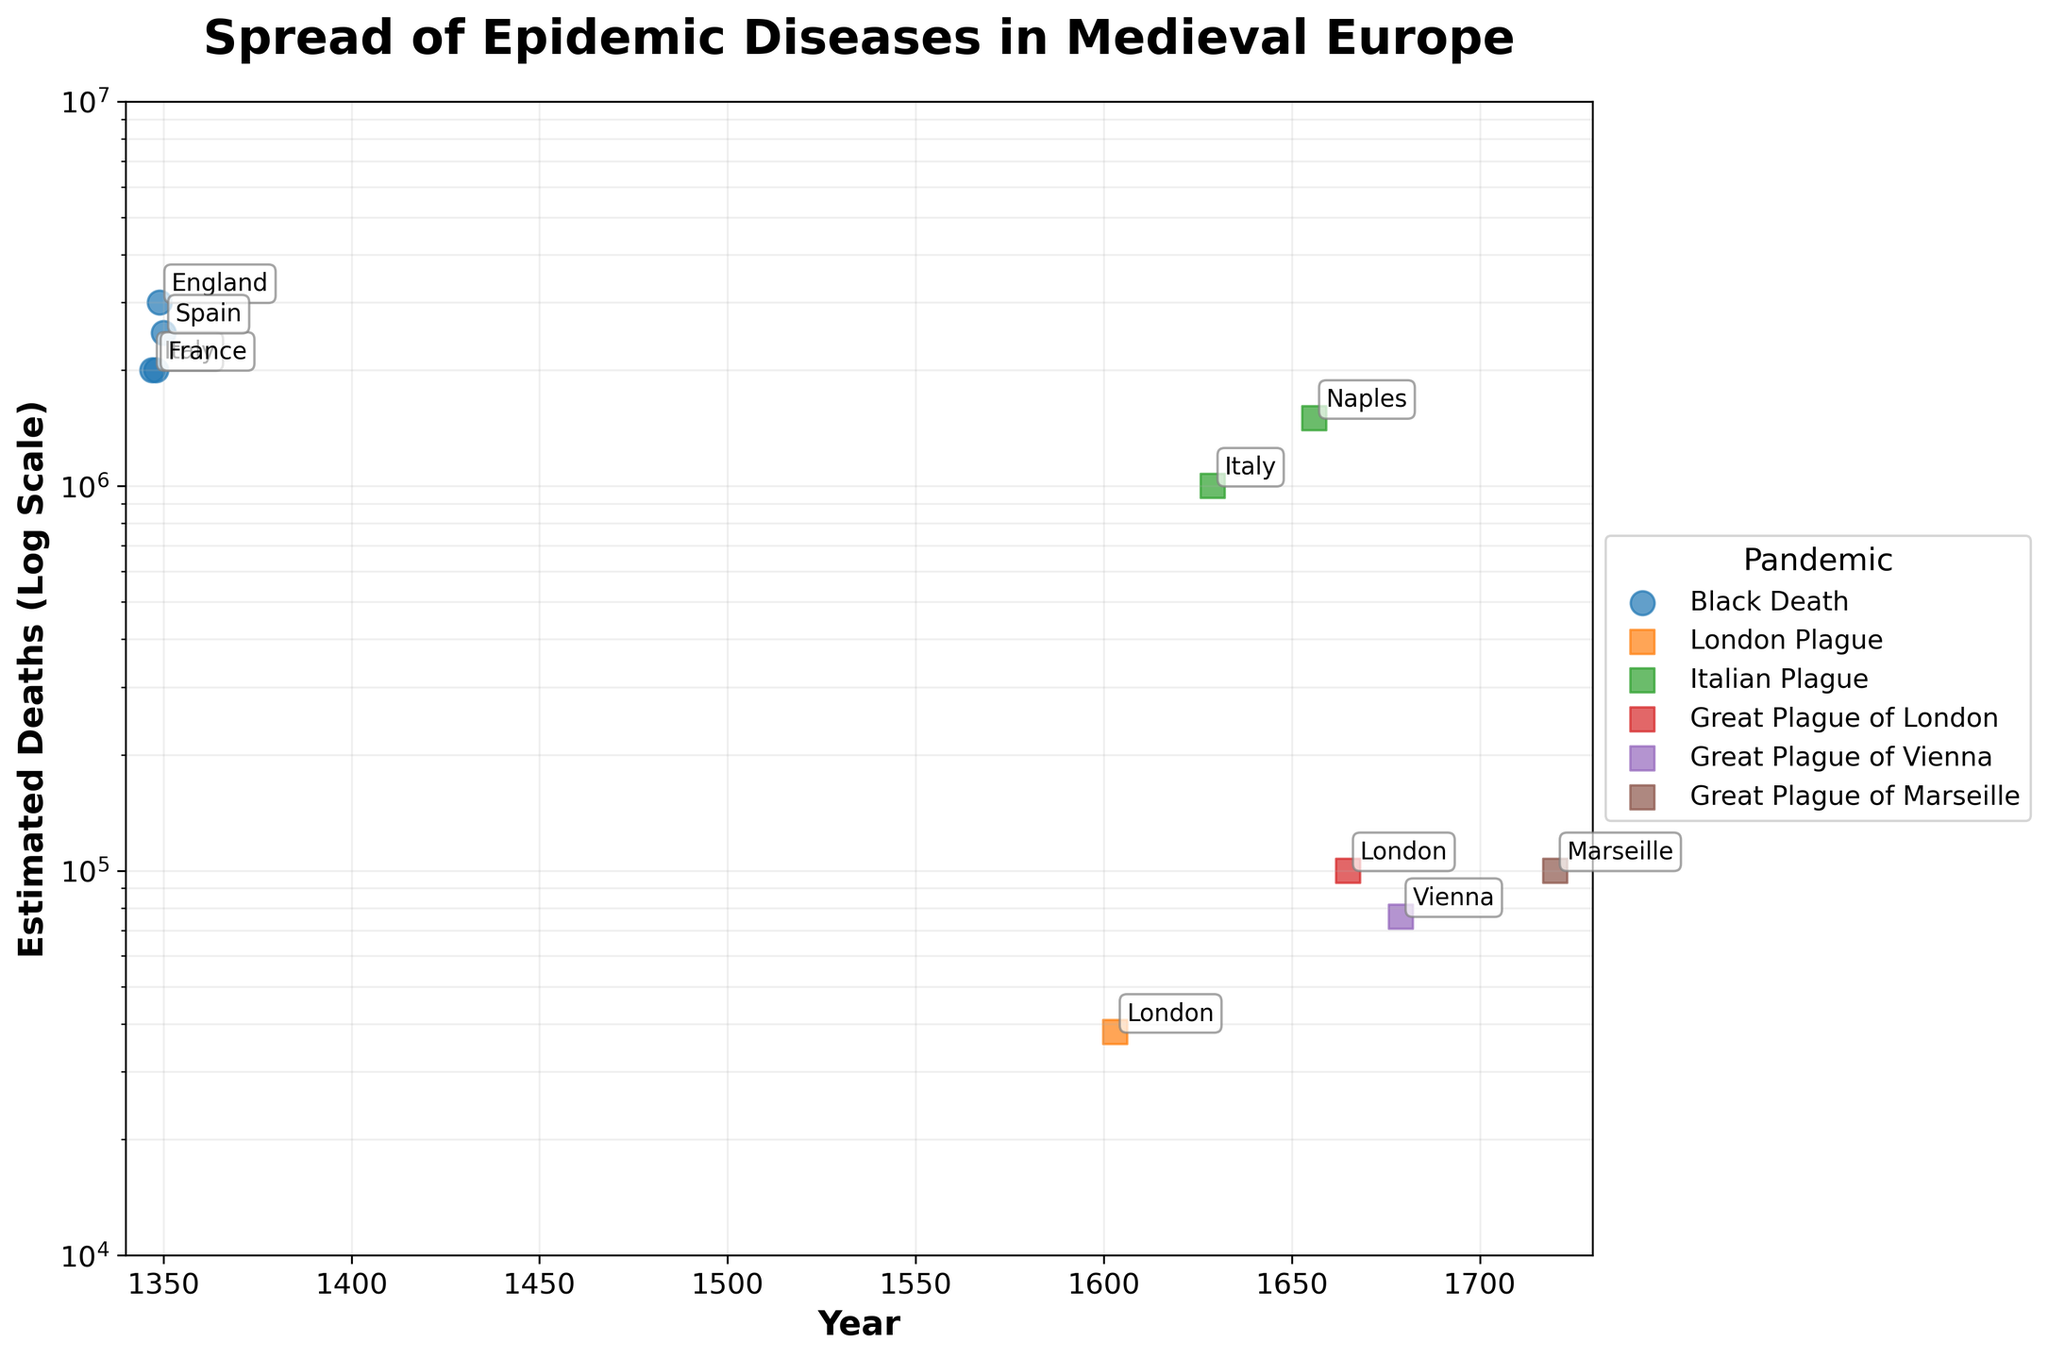What is the title of the figure? The title of the figure is usually found at the top of the graph in larger and bolder text than other elements. In this case, it is "Spread of Epidemic Diseases in Medieval Europe".
Answer: Spread of Epidemic Diseases in Medieval Europe What is the y-axis representing in the figure? The y-axis represents the "Estimated Deaths (Log Scale)". This is inferred from the label on the y-axis.
Answer: Estimated Deaths (Log Scale) How many pandemics are shown in the figure? By looking at the number of unique labels in the legend, we count the different pandemics listed. The unique pandemics are "Black Death", "London Plague", "Italian Plague", "Great Plague of London", "Great Plague of Vienna", and "Great Plague of Marseille". That makes 6 pandemics in total.
Answer: 6 Which region experienced the highest estimated deaths and during which pandemic? The highest death counts can be identified by looking for the tallest point on the y-axis in the log scale, which represents the largest number. We see that "England" in 1349 during the "Black Death" has the highest count of 3,000,000.
Answer: England in 1349 during the Black Death What years does the figure cover? The x-axis represents the year, and based on the x-axis limits, it ranges from 1340 to 1730.
Answer: 1340 to 1730 Compare the number of deaths during the "Great Plague of London" and the "Great Plague of Vienna." Which had more deaths? The deaths during the "Great Plague of London" in 1665 were 100,000, and the deaths during the "Great Plague of Vienna" in 1679 were 76,000. Therefore, the "Great Plague of London" had more deaths.
Answer: Great Plague of London What is the difference in the number of deaths between the 1347 "Black Death" in Italy and the 1629 "Italian Plague" in Italy? The 1347 Black Death in Italy had 2,000,000 estimated deaths, while the 1629 Italian Plague had 1,000,000 estimated deaths. The difference is calculated as 2,000,000 - 1,000,000 = 1,000,000.
Answer: 1,000,000 Identify the region with the smallest number of deaths and specify the year and pandemic. By examining the points at the lower end of the y-axis on the log scale, we notice the smallest number of deaths at 38,000 in London during the "London Plague" of 1603.
Answer: London in 1603 during the London Plague How does the scale of the y-axis affect the visual representation of the data? The log scale of the y-axis compresses the range of values, which allows us to better visualize differences in orders of magnitude. This reveals patterns and relationships in data that would be harder to identify on a linear scale. For example, small outbreaks remain visible, while large outbreaks do not dominate the entire visual space.
Answer: Compresses the range for better differentiation of orders of magnitude 